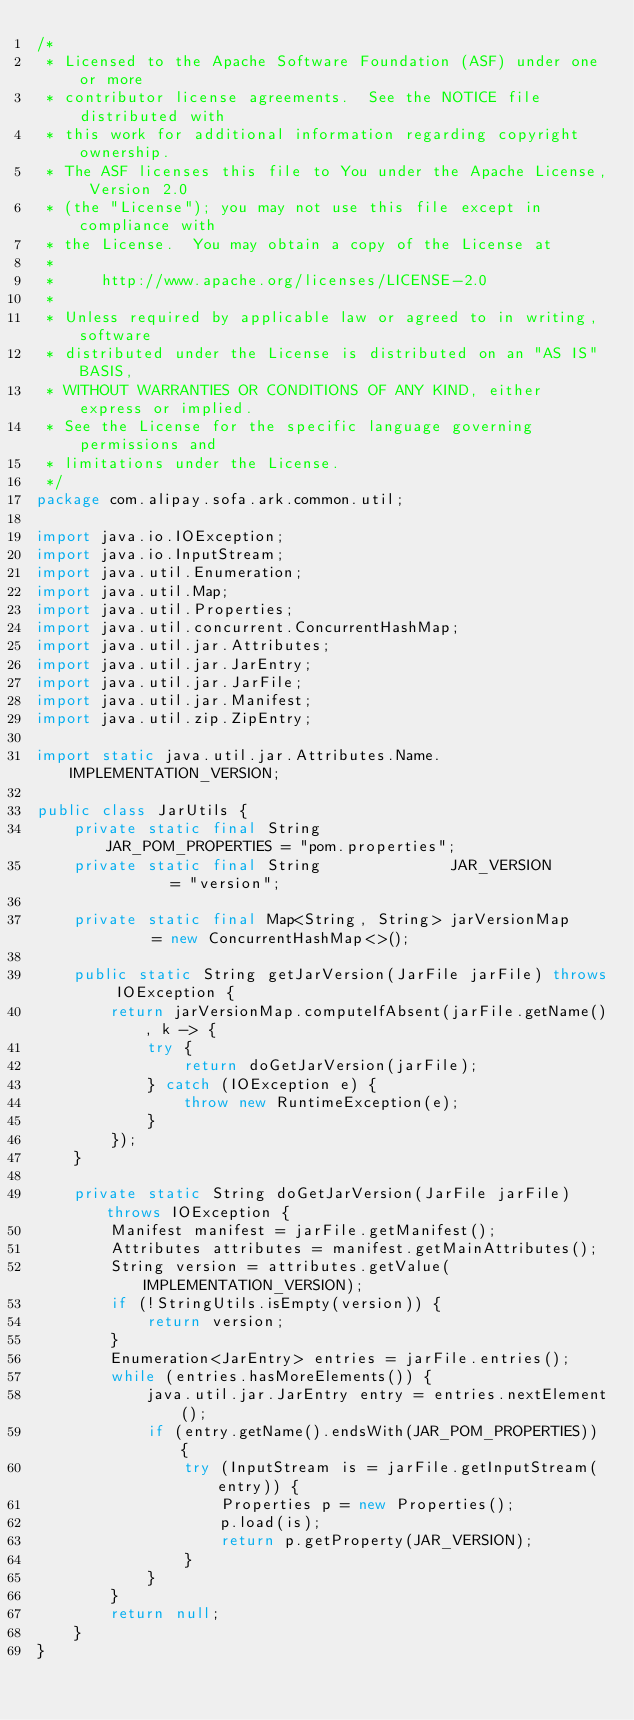<code> <loc_0><loc_0><loc_500><loc_500><_Java_>/*
 * Licensed to the Apache Software Foundation (ASF) under one or more
 * contributor license agreements.  See the NOTICE file distributed with
 * this work for additional information regarding copyright ownership.
 * The ASF licenses this file to You under the Apache License, Version 2.0
 * (the "License"); you may not use this file except in compliance with
 * the License.  You may obtain a copy of the License at
 *
 *     http://www.apache.org/licenses/LICENSE-2.0
 *
 * Unless required by applicable law or agreed to in writing, software
 * distributed under the License is distributed on an "AS IS" BASIS,
 * WITHOUT WARRANTIES OR CONDITIONS OF ANY KIND, either express or implied.
 * See the License for the specific language governing permissions and
 * limitations under the License.
 */
package com.alipay.sofa.ark.common.util;

import java.io.IOException;
import java.io.InputStream;
import java.util.Enumeration;
import java.util.Map;
import java.util.Properties;
import java.util.concurrent.ConcurrentHashMap;
import java.util.jar.Attributes;
import java.util.jar.JarEntry;
import java.util.jar.JarFile;
import java.util.jar.Manifest;
import java.util.zip.ZipEntry;

import static java.util.jar.Attributes.Name.IMPLEMENTATION_VERSION;

public class JarUtils {
    private static final String              JAR_POM_PROPERTIES = "pom.properties";
    private static final String              JAR_VERSION        = "version";

    private static final Map<String, String> jarVersionMap      = new ConcurrentHashMap<>();

    public static String getJarVersion(JarFile jarFile) throws IOException {
        return jarVersionMap.computeIfAbsent(jarFile.getName(), k -> {
            try {
                return doGetJarVersion(jarFile);
            } catch (IOException e) {
                throw new RuntimeException(e);
            }
        });
    }

    private static String doGetJarVersion(JarFile jarFile) throws IOException {
        Manifest manifest = jarFile.getManifest();
        Attributes attributes = manifest.getMainAttributes();
        String version = attributes.getValue(IMPLEMENTATION_VERSION);
        if (!StringUtils.isEmpty(version)) {
            return version;
        }
        Enumeration<JarEntry> entries = jarFile.entries();
        while (entries.hasMoreElements()) {
            java.util.jar.JarEntry entry = entries.nextElement();
            if (entry.getName().endsWith(JAR_POM_PROPERTIES)) {
                try (InputStream is = jarFile.getInputStream(entry)) {
                    Properties p = new Properties();
                    p.load(is);
                    return p.getProperty(JAR_VERSION);
                }
            }
        }
        return null;
    }
}
</code> 